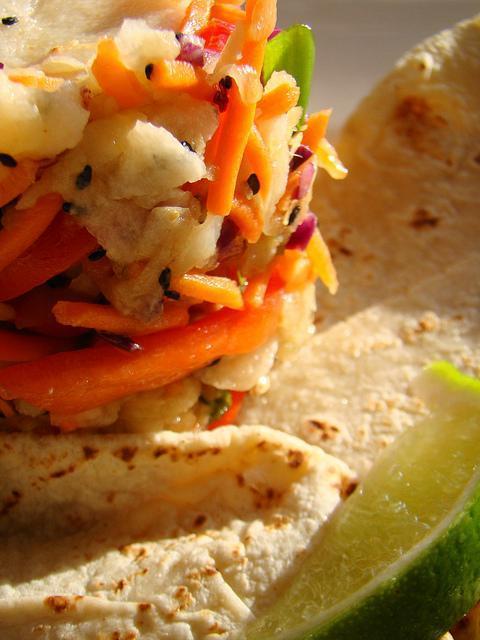How many carrots can be seen?
Give a very brief answer. 7. 